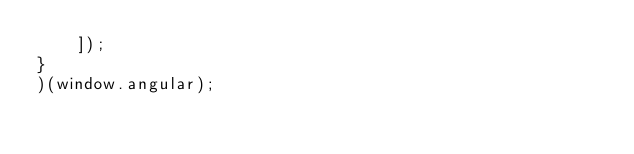Convert code to text. <code><loc_0><loc_0><loc_500><loc_500><_JavaScript_>    ]);
}
)(window.angular);
</code> 